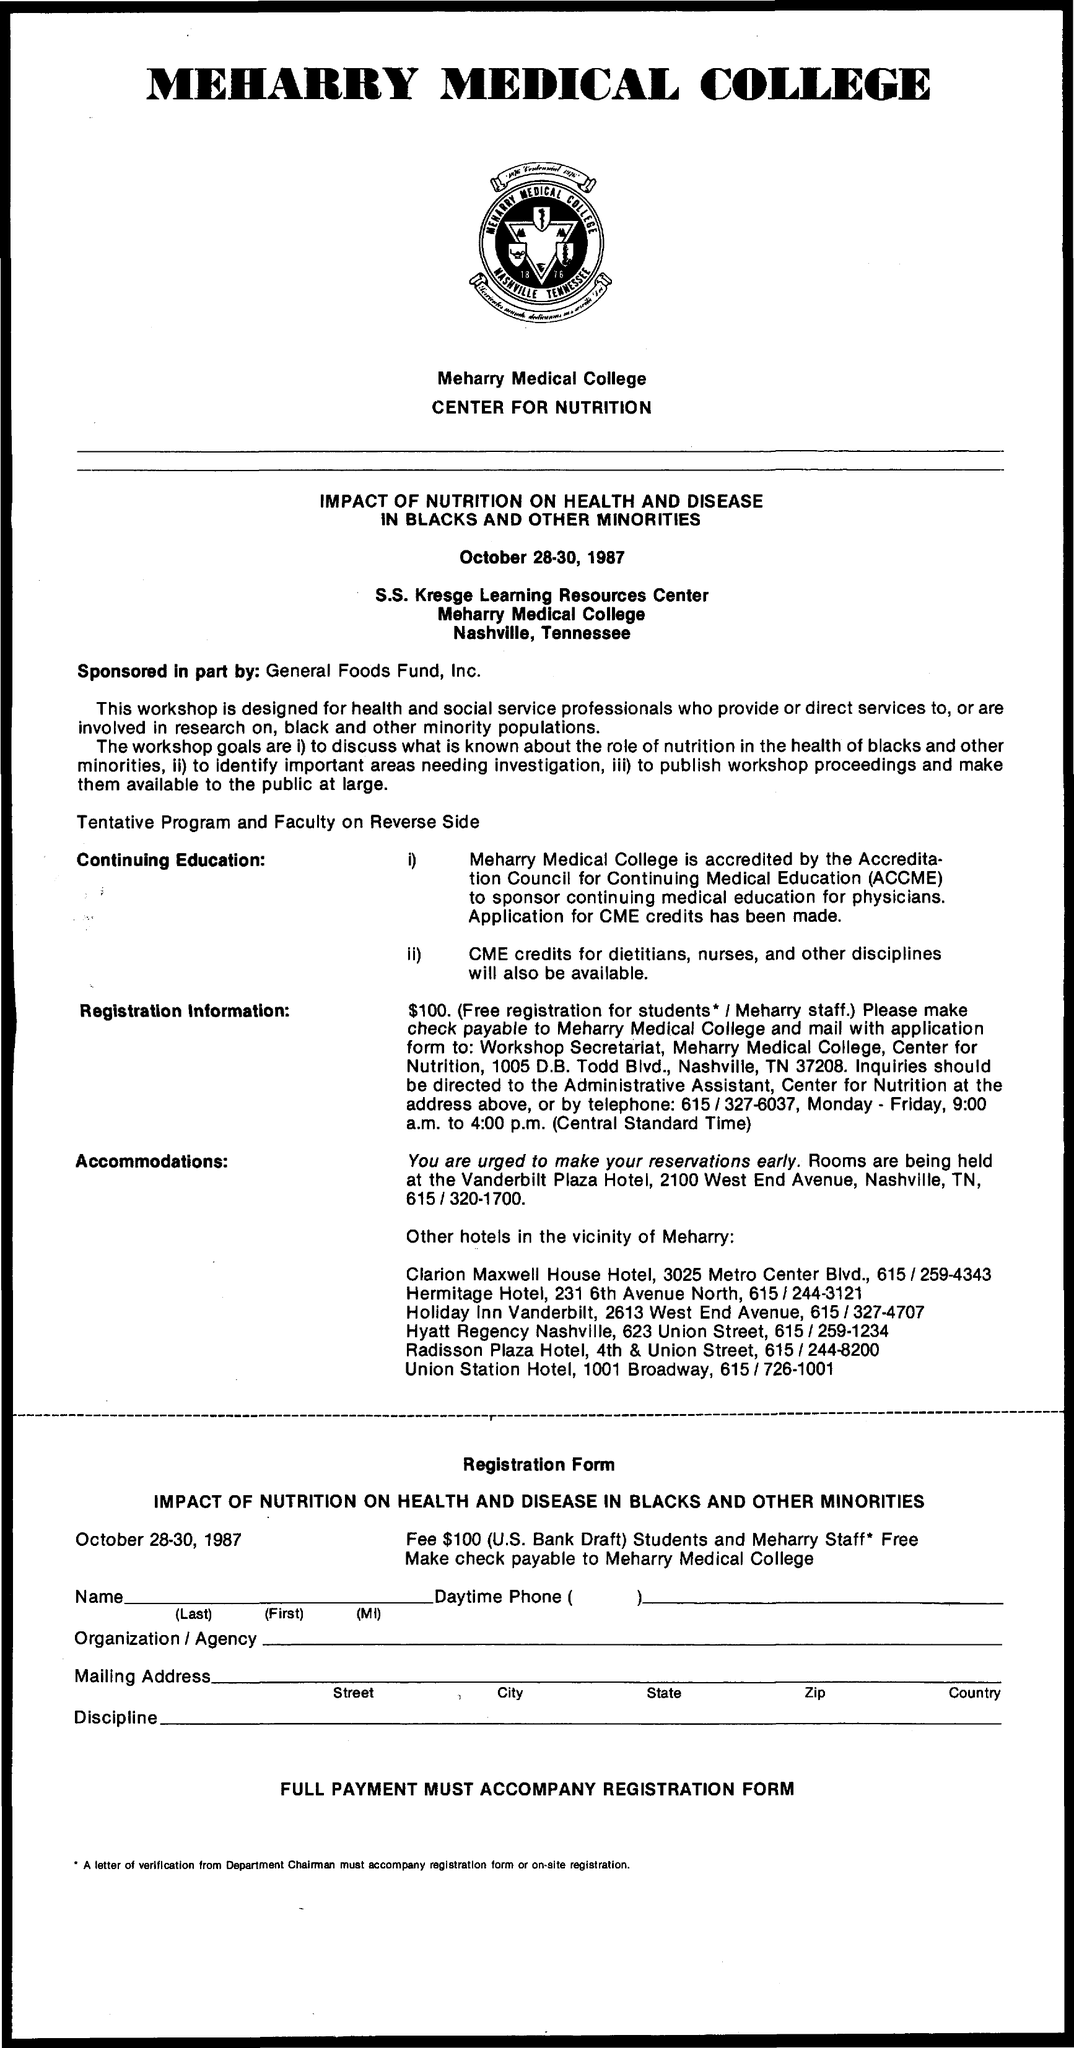What is the name of the college mentioned ?
Your answer should be compact. MEHARRY MEDICAL COLLEGE. What are the dates mentioned ?
Offer a very short reply. OCTOBER 28-30, 1987. 